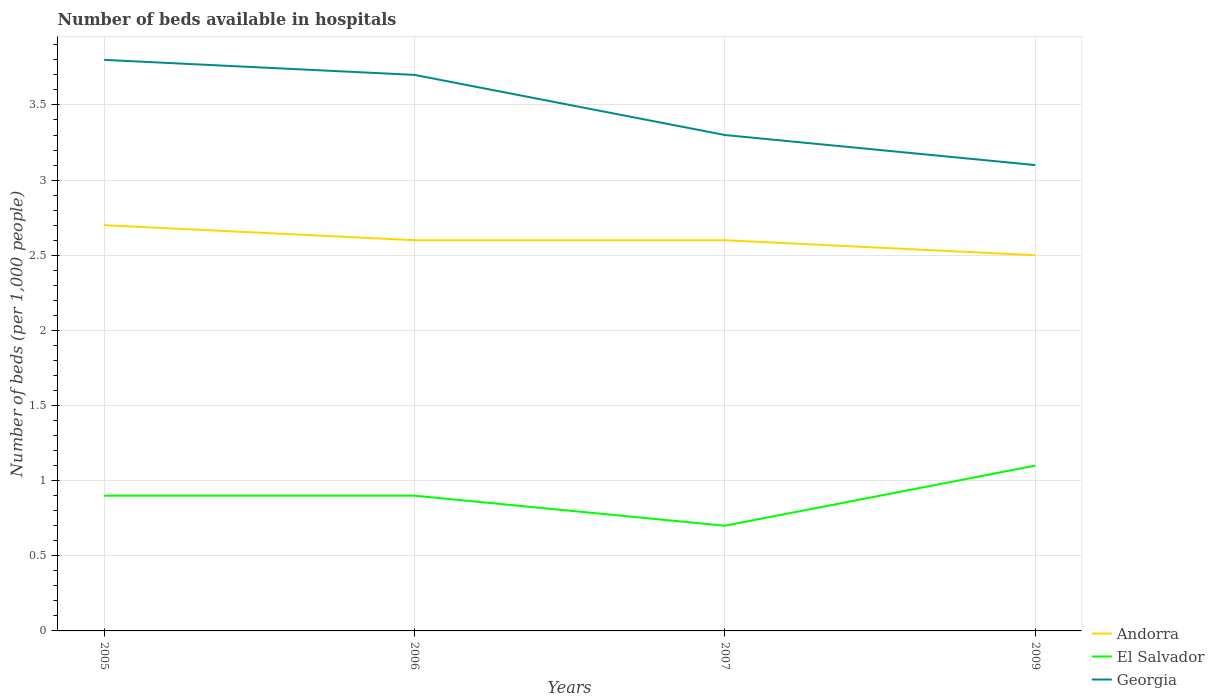Does the line corresponding to Georgia intersect with the line corresponding to El Salvador?
Keep it short and to the point. No. In which year was the number of beds in the hospiatls of in Andorra maximum?
Make the answer very short. 2009. What is the total number of beds in the hospiatls of in Andorra in the graph?
Provide a short and direct response. 0.1. What is the difference between the highest and the second highest number of beds in the hospiatls of in Andorra?
Offer a very short reply. 0.2. What is the difference between the highest and the lowest number of beds in the hospiatls of in Andorra?
Offer a very short reply. 1. Are the values on the major ticks of Y-axis written in scientific E-notation?
Provide a succinct answer. No. Where does the legend appear in the graph?
Keep it short and to the point. Bottom right. How many legend labels are there?
Offer a terse response. 3. What is the title of the graph?
Your answer should be very brief. Number of beds available in hospitals. Does "Colombia" appear as one of the legend labels in the graph?
Offer a terse response. No. What is the label or title of the X-axis?
Provide a succinct answer. Years. What is the label or title of the Y-axis?
Offer a very short reply. Number of beds (per 1,0 people). What is the Number of beds (per 1,000 people) of Andorra in 2005?
Give a very brief answer. 2.7. What is the Number of beds (per 1,000 people) in El Salvador in 2005?
Give a very brief answer. 0.9. What is the Number of beds (per 1,000 people) of Georgia in 2005?
Give a very brief answer. 3.8. What is the Number of beds (per 1,000 people) of Georgia in 2006?
Keep it short and to the point. 3.7. What is the Number of beds (per 1,000 people) of Andorra in 2007?
Offer a very short reply. 2.6. What is the Number of beds (per 1,000 people) of El Salvador in 2007?
Provide a short and direct response. 0.7. What is the Number of beds (per 1,000 people) of El Salvador in 2009?
Provide a succinct answer. 1.1. Across all years, what is the maximum Number of beds (per 1,000 people) of Andorra?
Your answer should be compact. 2.7. Across all years, what is the maximum Number of beds (per 1,000 people) in El Salvador?
Provide a succinct answer. 1.1. Across all years, what is the minimum Number of beds (per 1,000 people) in Georgia?
Make the answer very short. 3.1. What is the total Number of beds (per 1,000 people) in Georgia in the graph?
Keep it short and to the point. 13.9. What is the difference between the Number of beds (per 1,000 people) of Andorra in 2005 and that in 2006?
Provide a short and direct response. 0.1. What is the difference between the Number of beds (per 1,000 people) in Georgia in 2005 and that in 2006?
Provide a succinct answer. 0.1. What is the difference between the Number of beds (per 1,000 people) in Andorra in 2005 and that in 2007?
Ensure brevity in your answer.  0.1. What is the difference between the Number of beds (per 1,000 people) of El Salvador in 2005 and that in 2007?
Provide a short and direct response. 0.2. What is the difference between the Number of beds (per 1,000 people) of Andorra in 2006 and that in 2007?
Give a very brief answer. 0. What is the difference between the Number of beds (per 1,000 people) in El Salvador in 2006 and that in 2007?
Keep it short and to the point. 0.2. What is the difference between the Number of beds (per 1,000 people) in Andorra in 2007 and that in 2009?
Your answer should be very brief. 0.1. What is the difference between the Number of beds (per 1,000 people) of El Salvador in 2007 and that in 2009?
Offer a terse response. -0.4. What is the difference between the Number of beds (per 1,000 people) in Andorra in 2005 and the Number of beds (per 1,000 people) in Georgia in 2006?
Offer a terse response. -1. What is the difference between the Number of beds (per 1,000 people) in Andorra in 2005 and the Number of beds (per 1,000 people) in Georgia in 2007?
Offer a terse response. -0.6. What is the difference between the Number of beds (per 1,000 people) in El Salvador in 2005 and the Number of beds (per 1,000 people) in Georgia in 2007?
Provide a short and direct response. -2.4. What is the difference between the Number of beds (per 1,000 people) in El Salvador in 2005 and the Number of beds (per 1,000 people) in Georgia in 2009?
Keep it short and to the point. -2.2. What is the difference between the Number of beds (per 1,000 people) of Andorra in 2006 and the Number of beds (per 1,000 people) of El Salvador in 2007?
Ensure brevity in your answer.  1.9. What is the difference between the Number of beds (per 1,000 people) in El Salvador in 2006 and the Number of beds (per 1,000 people) in Georgia in 2007?
Offer a very short reply. -2.4. What is the difference between the Number of beds (per 1,000 people) of Andorra in 2006 and the Number of beds (per 1,000 people) of El Salvador in 2009?
Keep it short and to the point. 1.5. What is the difference between the Number of beds (per 1,000 people) in Andorra in 2007 and the Number of beds (per 1,000 people) in El Salvador in 2009?
Provide a short and direct response. 1.5. What is the difference between the Number of beds (per 1,000 people) of Andorra in 2007 and the Number of beds (per 1,000 people) of Georgia in 2009?
Offer a very short reply. -0.5. What is the difference between the Number of beds (per 1,000 people) of El Salvador in 2007 and the Number of beds (per 1,000 people) of Georgia in 2009?
Give a very brief answer. -2.4. What is the average Number of beds (per 1,000 people) in El Salvador per year?
Give a very brief answer. 0.9. What is the average Number of beds (per 1,000 people) in Georgia per year?
Give a very brief answer. 3.48. In the year 2005, what is the difference between the Number of beds (per 1,000 people) in Andorra and Number of beds (per 1,000 people) in El Salvador?
Provide a succinct answer. 1.8. In the year 2006, what is the difference between the Number of beds (per 1,000 people) in Andorra and Number of beds (per 1,000 people) in Georgia?
Your answer should be very brief. -1.1. In the year 2007, what is the difference between the Number of beds (per 1,000 people) in El Salvador and Number of beds (per 1,000 people) in Georgia?
Your response must be concise. -2.6. In the year 2009, what is the difference between the Number of beds (per 1,000 people) in Andorra and Number of beds (per 1,000 people) in Georgia?
Offer a very short reply. -0.6. What is the ratio of the Number of beds (per 1,000 people) in Andorra in 2005 to that in 2007?
Give a very brief answer. 1.04. What is the ratio of the Number of beds (per 1,000 people) of Georgia in 2005 to that in 2007?
Your answer should be compact. 1.15. What is the ratio of the Number of beds (per 1,000 people) of Andorra in 2005 to that in 2009?
Make the answer very short. 1.08. What is the ratio of the Number of beds (per 1,000 people) in El Salvador in 2005 to that in 2009?
Provide a short and direct response. 0.82. What is the ratio of the Number of beds (per 1,000 people) in Georgia in 2005 to that in 2009?
Your answer should be very brief. 1.23. What is the ratio of the Number of beds (per 1,000 people) of Georgia in 2006 to that in 2007?
Provide a succinct answer. 1.12. What is the ratio of the Number of beds (per 1,000 people) of Andorra in 2006 to that in 2009?
Offer a terse response. 1.04. What is the ratio of the Number of beds (per 1,000 people) in El Salvador in 2006 to that in 2009?
Provide a succinct answer. 0.82. What is the ratio of the Number of beds (per 1,000 people) of Georgia in 2006 to that in 2009?
Give a very brief answer. 1.19. What is the ratio of the Number of beds (per 1,000 people) of El Salvador in 2007 to that in 2009?
Keep it short and to the point. 0.64. What is the ratio of the Number of beds (per 1,000 people) of Georgia in 2007 to that in 2009?
Give a very brief answer. 1.06. What is the difference between the highest and the second highest Number of beds (per 1,000 people) of Andorra?
Offer a terse response. 0.1. What is the difference between the highest and the second highest Number of beds (per 1,000 people) of El Salvador?
Give a very brief answer. 0.2. What is the difference between the highest and the lowest Number of beds (per 1,000 people) of El Salvador?
Provide a short and direct response. 0.4. What is the difference between the highest and the lowest Number of beds (per 1,000 people) in Georgia?
Provide a short and direct response. 0.7. 